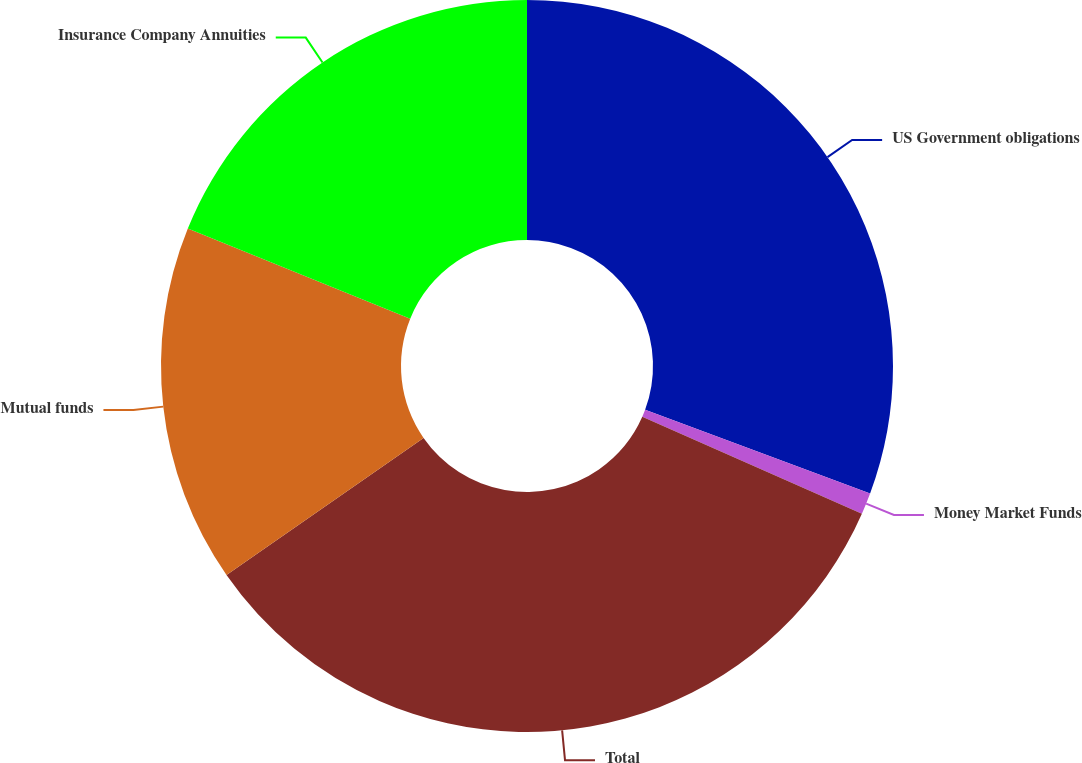Convert chart. <chart><loc_0><loc_0><loc_500><loc_500><pie_chart><fcel>US Government obligations<fcel>Money Market Funds<fcel>Total<fcel>Mutual funds<fcel>Insurance Company Annuities<nl><fcel>30.66%<fcel>0.95%<fcel>33.72%<fcel>15.8%<fcel>18.87%<nl></chart> 